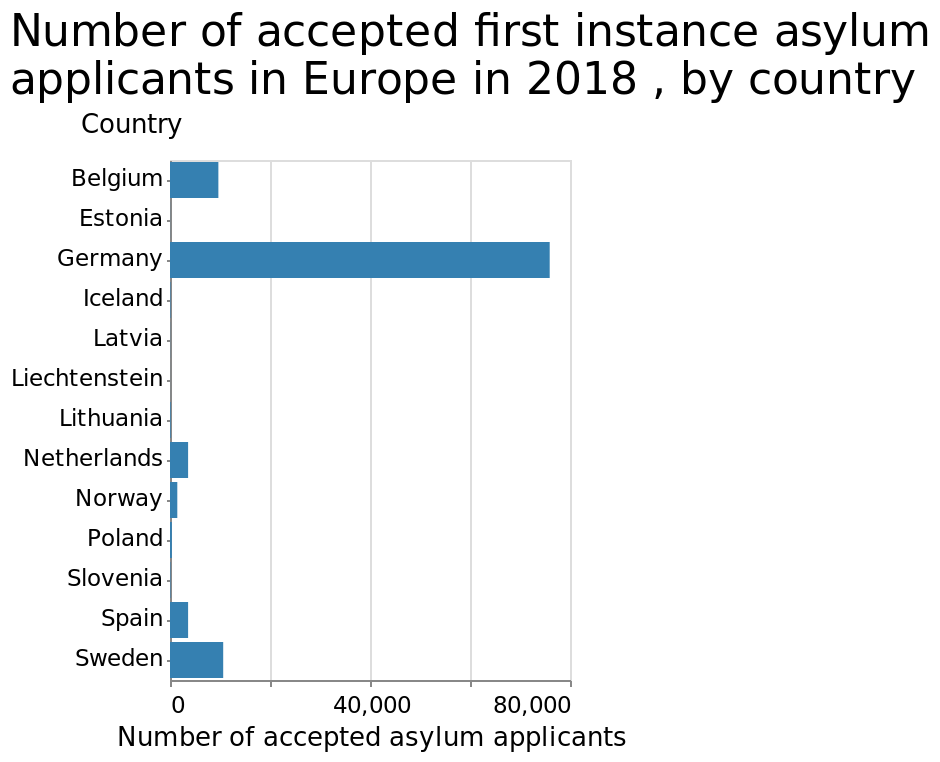<image>
How is the number of accepted asylum applicants measured and what are the limits of the measurement?  The number of accepted asylum applicants is measured with a linear scale. It ranges from a minimum of 0 to a maximum of 80,000 along the x-axis. What does the bar plot represent?  The bar plot represents the number of accepted first instance asylum applicants in Europe in 2018 for each country. 